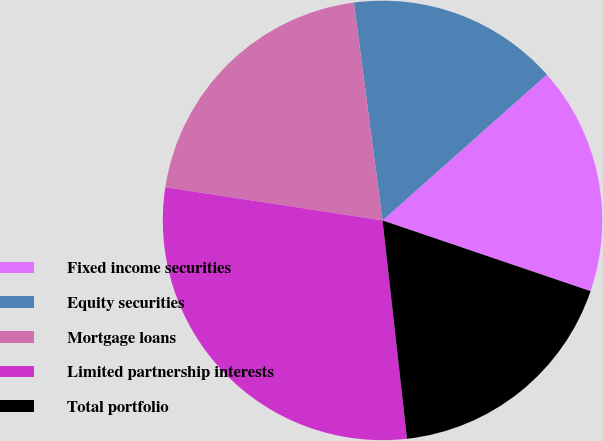Convert chart to OTSL. <chart><loc_0><loc_0><loc_500><loc_500><pie_chart><fcel>Fixed income securities<fcel>Equity securities<fcel>Mortgage loans<fcel>Limited partnership interests<fcel>Total portfolio<nl><fcel>16.77%<fcel>15.53%<fcel>20.5%<fcel>29.19%<fcel>18.01%<nl></chart> 